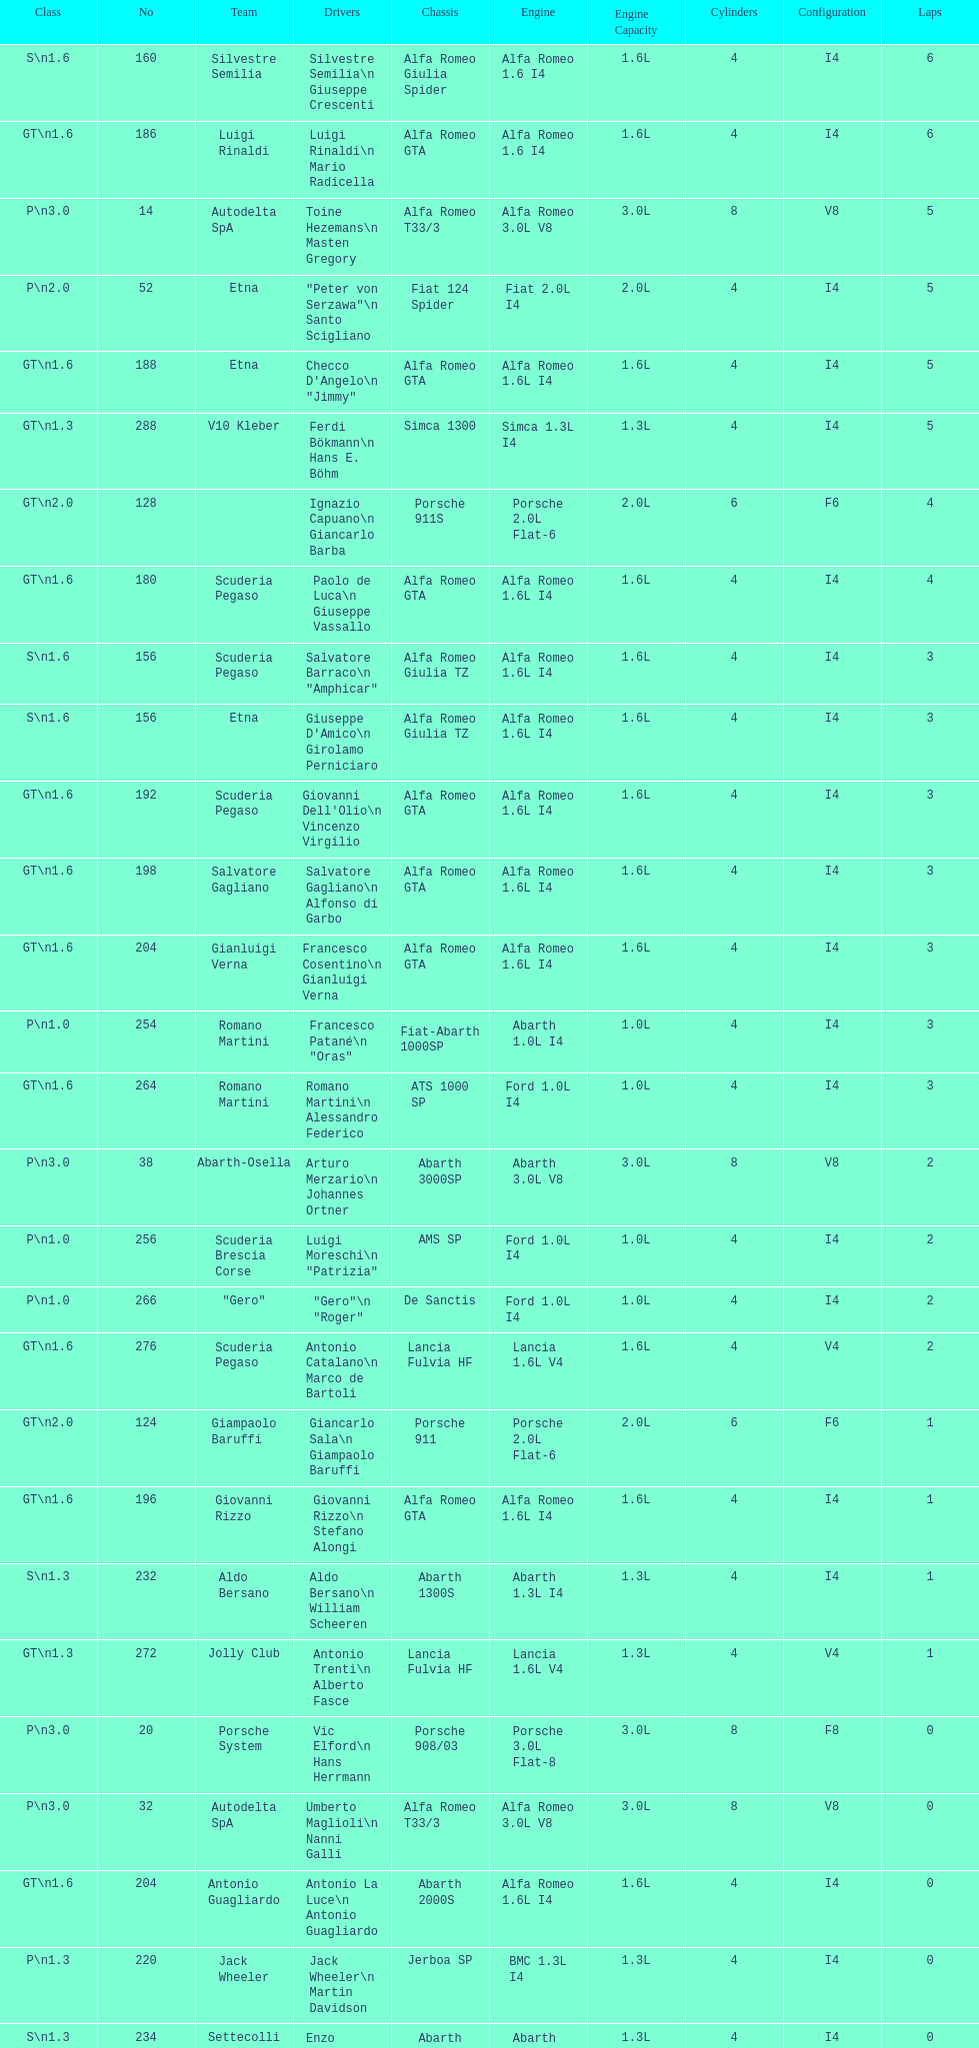Which chassis is in the middle of simca 1300 and alfa romeo gta? Porsche 911S. 